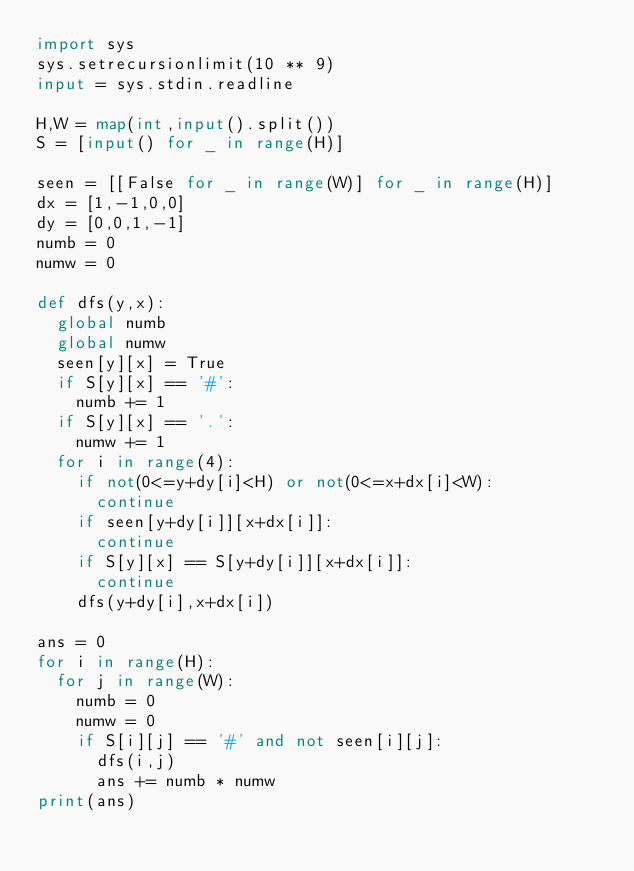Convert code to text. <code><loc_0><loc_0><loc_500><loc_500><_Python_>import sys
sys.setrecursionlimit(10 ** 9)
input = sys.stdin.readline

H,W = map(int,input().split())
S = [input() for _ in range(H)]

seen = [[False for _ in range(W)] for _ in range(H)]
dx = [1,-1,0,0]
dy = [0,0,1,-1]
numb = 0
numw = 0

def dfs(y,x):
  global numb
  global numw
  seen[y][x] = True
  if S[y][x] == '#':
    numb += 1
  if S[y][x] == '.':
    numw += 1
  for i in range(4):
    if not(0<=y+dy[i]<H) or not(0<=x+dx[i]<W):
      continue
    if seen[y+dy[i]][x+dx[i]]:
      continue
    if S[y][x] == S[y+dy[i]][x+dx[i]]:
      continue
    dfs(y+dy[i],x+dx[i])

ans = 0
for i in range(H):
  for j in range(W):
    numb = 0
    numw = 0
    if S[i][j] == '#' and not seen[i][j]:
      dfs(i,j)
      ans += numb * numw
print(ans)
</code> 